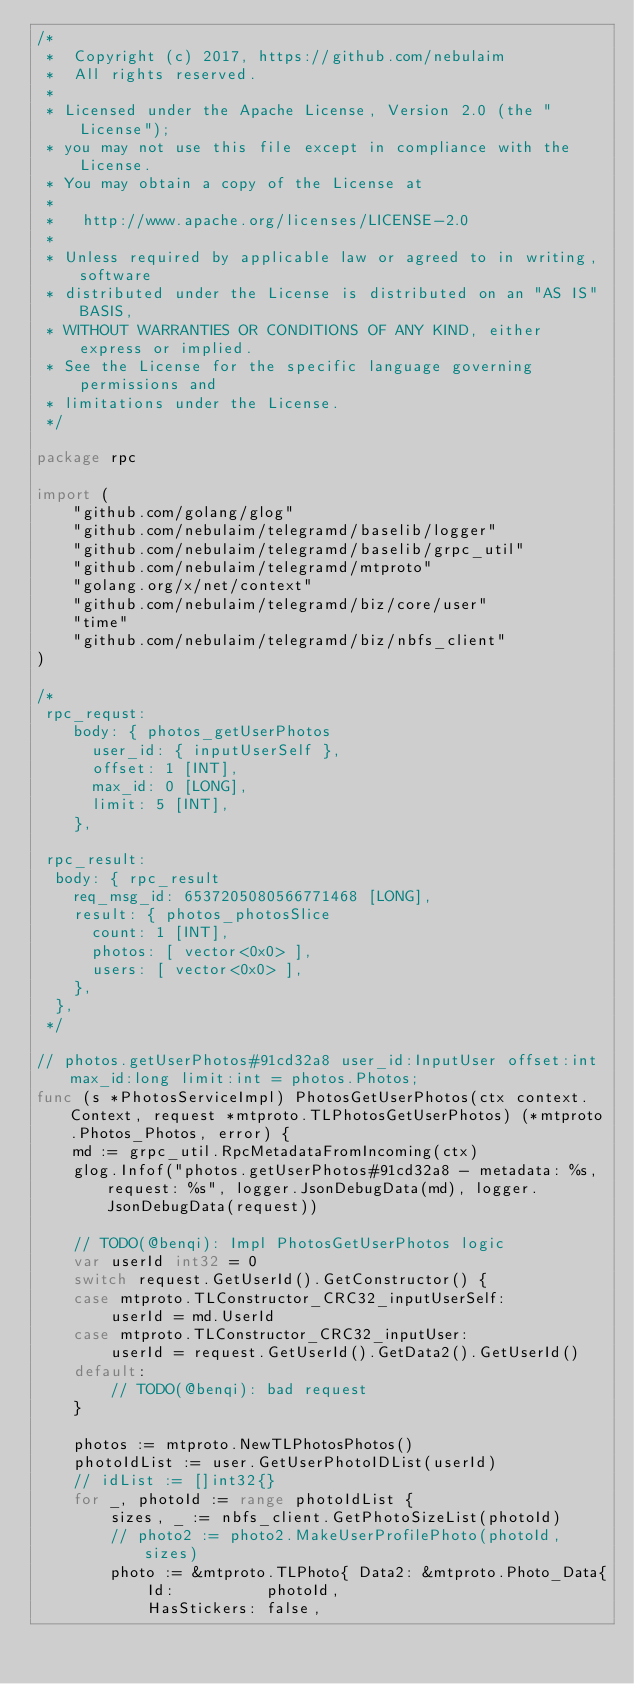Convert code to text. <code><loc_0><loc_0><loc_500><loc_500><_Go_>/*
 *  Copyright (c) 2017, https://github.com/nebulaim
 *  All rights reserved.
 *
 * Licensed under the Apache License, Version 2.0 (the "License");
 * you may not use this file except in compliance with the License.
 * You may obtain a copy of the License at
 *
 *   http://www.apache.org/licenses/LICENSE-2.0
 *
 * Unless required by applicable law or agreed to in writing, software
 * distributed under the License is distributed on an "AS IS" BASIS,
 * WITHOUT WARRANTIES OR CONDITIONS OF ANY KIND, either express or implied.
 * See the License for the specific language governing permissions and
 * limitations under the License.
 */

package rpc

import (
	"github.com/golang/glog"
	"github.com/nebulaim/telegramd/baselib/logger"
	"github.com/nebulaim/telegramd/baselib/grpc_util"
	"github.com/nebulaim/telegramd/mtproto"
	"golang.org/x/net/context"
	"github.com/nebulaim/telegramd/biz/core/user"
	"time"
	"github.com/nebulaim/telegramd/biz/nbfs_client"
)

/*
 rpc_requst:
	body: { photos_getUserPhotos
	  user_id: { inputUserSelf },
	  offset: 1 [INT],
	  max_id: 0 [LONG],
	  limit: 5 [INT],
	},

 rpc_result:
  body: { rpc_result
    req_msg_id: 6537205080566771468 [LONG],
    result: { photos_photosSlice
      count: 1 [INT],
      photos: [ vector<0x0> ],
      users: [ vector<0x0> ],
    },
  },
 */

// photos.getUserPhotos#91cd32a8 user_id:InputUser offset:int max_id:long limit:int = photos.Photos;
func (s *PhotosServiceImpl) PhotosGetUserPhotos(ctx context.Context, request *mtproto.TLPhotosGetUserPhotos) (*mtproto.Photos_Photos, error) {
	md := grpc_util.RpcMetadataFromIncoming(ctx)
	glog.Infof("photos.getUserPhotos#91cd32a8 - metadata: %s, request: %s", logger.JsonDebugData(md), logger.JsonDebugData(request))

	// TODO(@benqi): Impl PhotosGetUserPhotos logic
	var userId int32 = 0
	switch request.GetUserId().GetConstructor() {
	case mtproto.TLConstructor_CRC32_inputUserSelf:
		userId = md.UserId
	case mtproto.TLConstructor_CRC32_inputUser:
		userId = request.GetUserId().GetData2().GetUserId()
	default:
		// TODO(@benqi): bad request
	}

	photos := mtproto.NewTLPhotosPhotos()
	photoIdList := user.GetUserPhotoIDList(userId)
	// idList := []int32{}
	for _, photoId := range photoIdList {
		sizes, _ := nbfs_client.GetPhotoSizeList(photoId)
		// photo2 := photo2.MakeUserProfilePhoto(photoId, sizes)
		photo := &mtproto.TLPhoto{ Data2: &mtproto.Photo_Data{
			Id:          photoId,
			HasStickers: false,</code> 